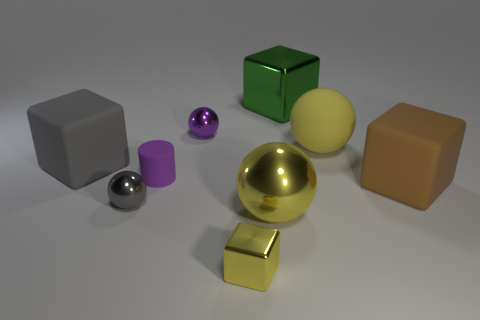There is a big object on the left side of the tiny shiny thing that is behind the gray matte cube that is behind the brown rubber thing; what is its shape?
Your response must be concise. Cube. What color is the other small metallic object that is the same shape as the green object?
Give a very brief answer. Yellow. There is a small thing in front of the tiny ball left of the small purple rubber cylinder; what is its color?
Offer a terse response. Yellow. There is a rubber thing that is the same shape as the gray metal thing; what is its size?
Provide a short and direct response. Large. What number of green objects have the same material as the small purple cylinder?
Keep it short and to the point. 0. There is a large yellow sphere in front of the tiny rubber cylinder; how many metal spheres are to the right of it?
Your answer should be very brief. 0. There is a small yellow block; are there any brown rubber things on the left side of it?
Provide a succinct answer. No. Is the shape of the big shiny thing that is in front of the tiny purple metallic sphere the same as  the small purple matte thing?
Your response must be concise. No. What material is the big thing that is the same color as the rubber sphere?
Offer a terse response. Metal. How many large blocks have the same color as the big metal sphere?
Offer a very short reply. 0. 